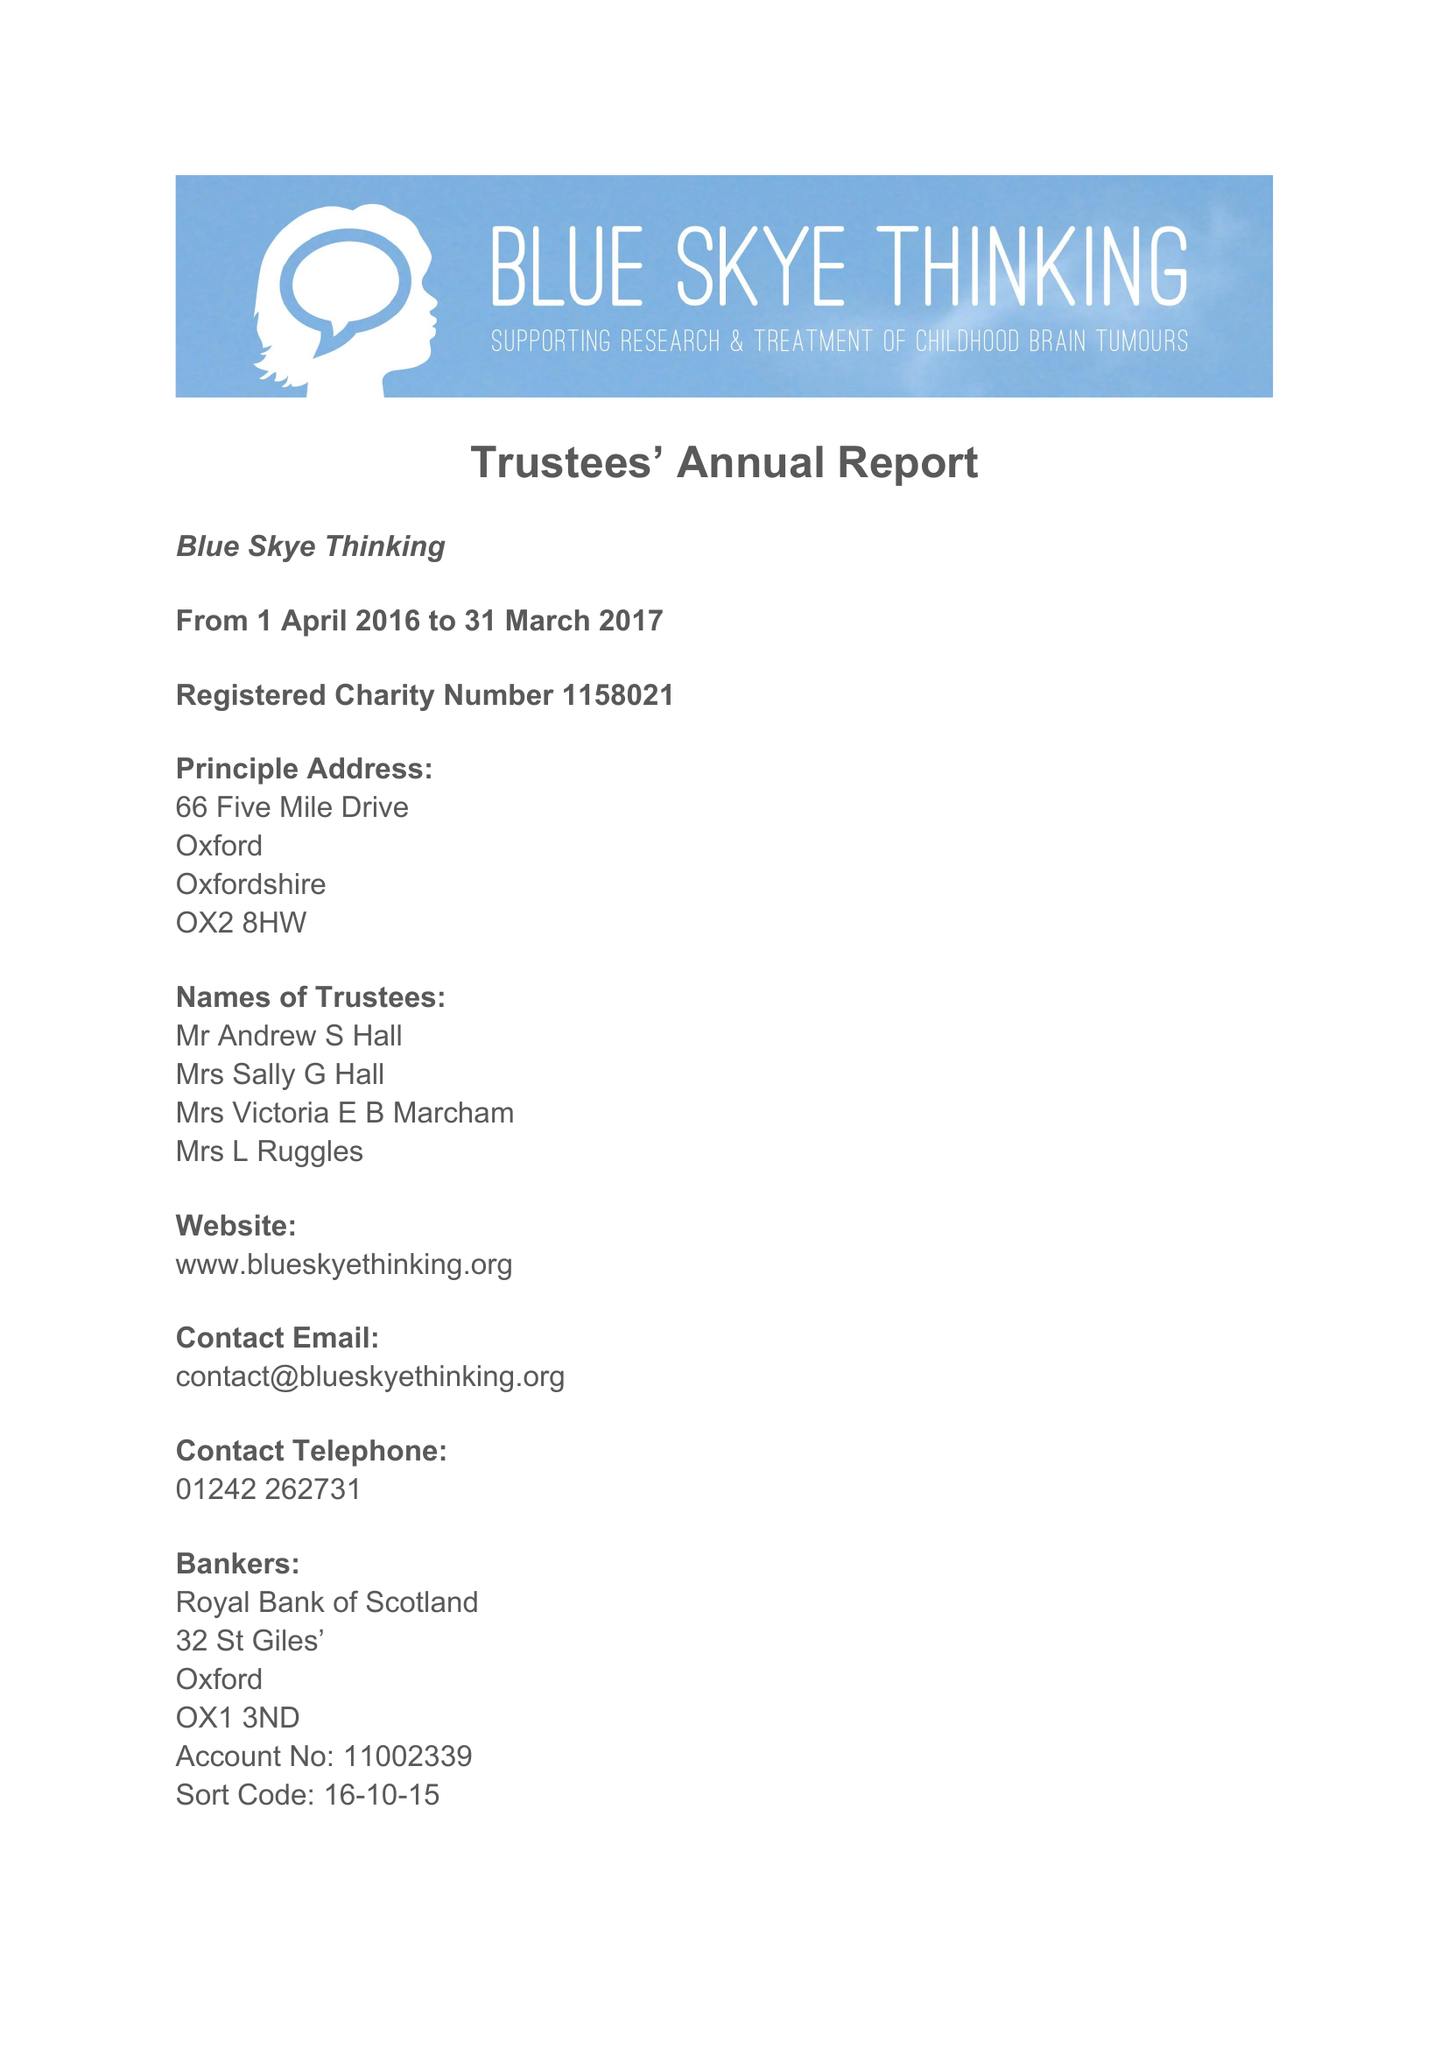What is the value for the income_annually_in_british_pounds?
Answer the question using a single word or phrase. 132817.00 